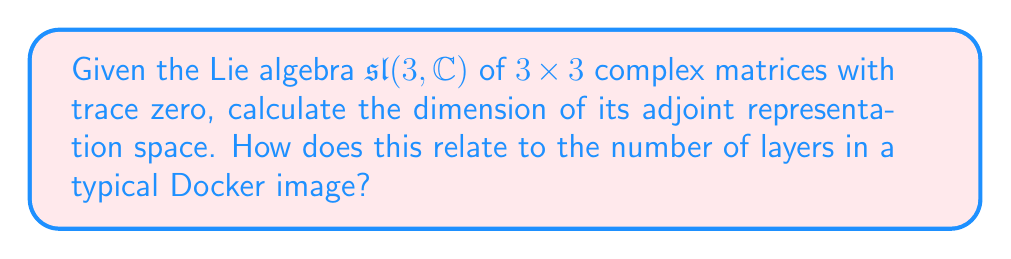What is the answer to this math problem? To solve this problem, we'll follow these steps:

1) The adjoint representation of a Lie algebra $\mathfrak{g}$ is the representation on itself, where $\mathfrak{g}$ acts on itself by the Lie bracket operation.

2) For $\mathfrak{sl}(3, \mathbb{C})$, we need to determine its dimension first:
   - $\mathfrak{sl}(3, \mathbb{C})$ consists of 3x3 matrices with trace zero
   - A general 3x3 matrix has 9 elements
   - The trace-zero condition imposes one constraint
   - Therefore, $\dim(\mathfrak{sl}(3, \mathbb{C})) = 9 - 1 = 8$

3) For any Lie algebra, the dimension of its adjoint representation space is equal to the dimension of the Lie algebra itself.

4) Thus, $\dim(\text{Ad}(\mathfrak{sl}(3, \mathbb{C}))) = 8$

Relating to Docker:
In Docker, images are built in layers, typically ranging from 5 to 15 layers for most applications. The dimension we calculated (8) falls within this range, which could be seen as an analogy to a moderately complex Docker image structure.
Answer: 8 